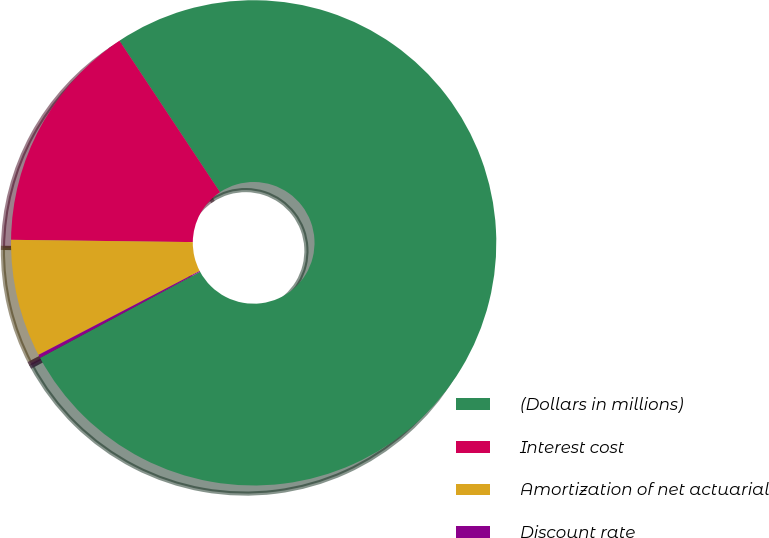<chart> <loc_0><loc_0><loc_500><loc_500><pie_chart><fcel>(Dollars in millions)<fcel>Interest cost<fcel>Amortization of net actuarial<fcel>Discount rate<nl><fcel>76.47%<fcel>15.47%<fcel>7.84%<fcel>0.22%<nl></chart> 